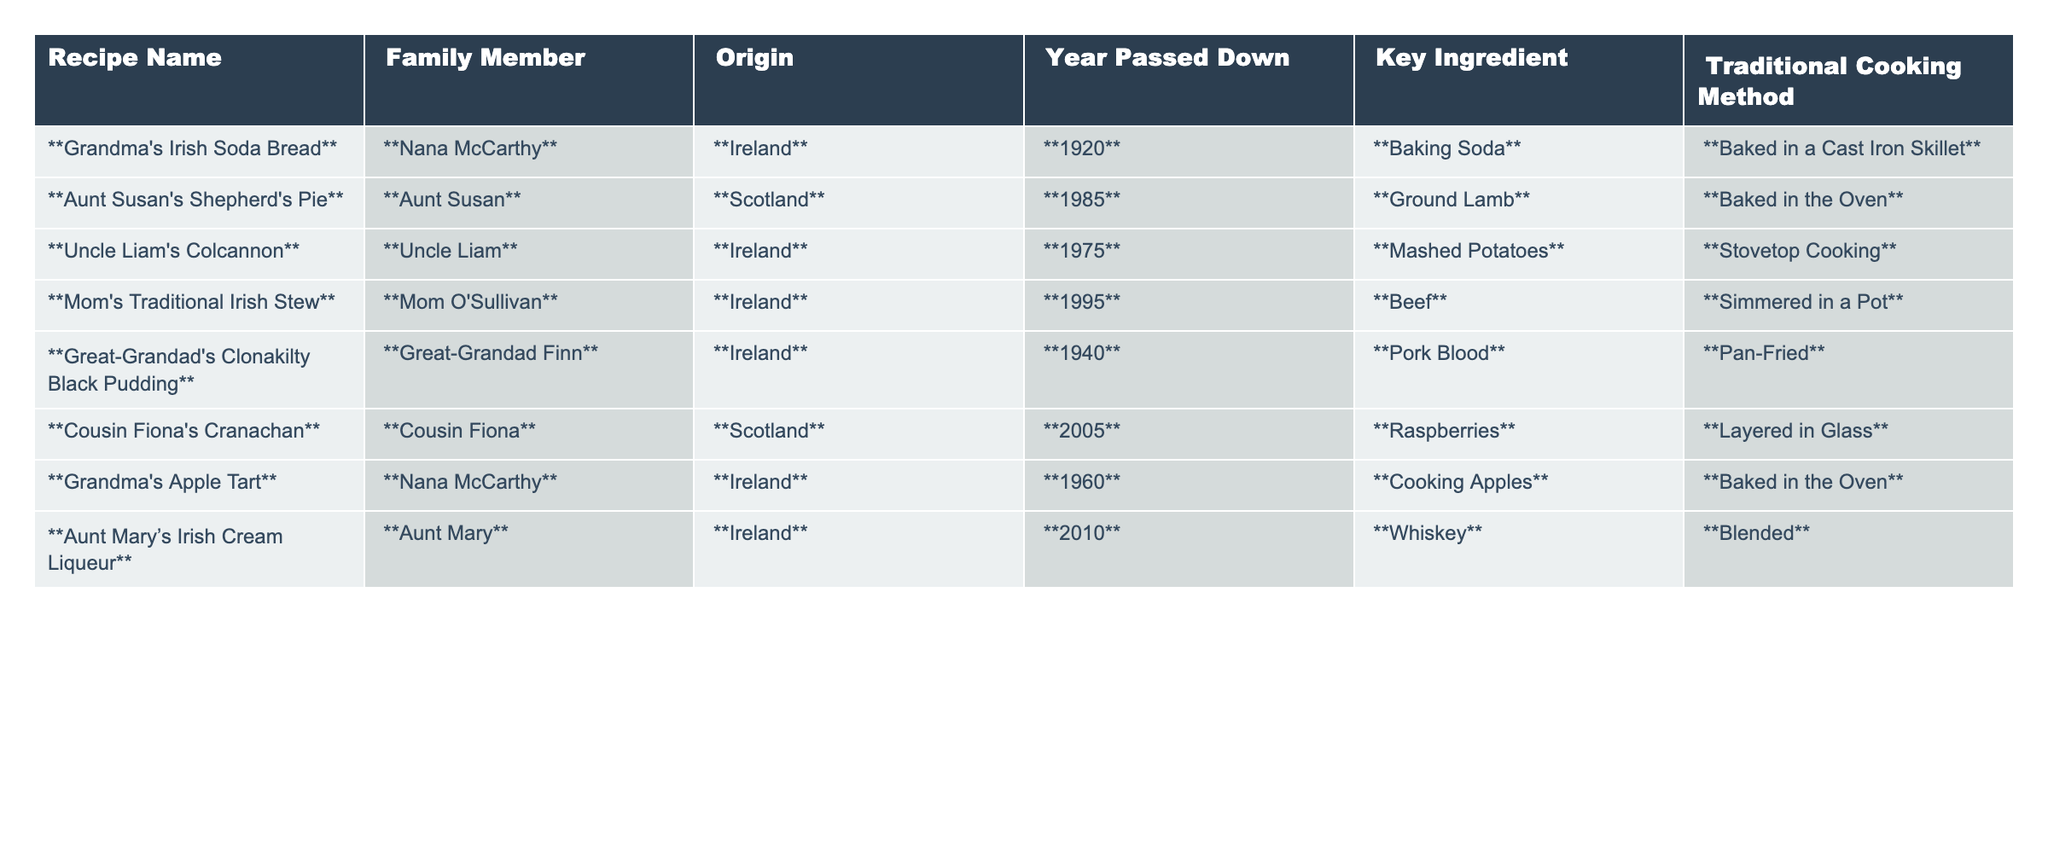What is the key ingredient in Grandma's Irish Soda Bread? The table shows that the key ingredient for Grandma's Irish Soda Bread is Baking Soda.
Answer: Baking Soda Which family member is associated with Aunt Susan's Shepherd's Pie? From the table, Aunt Susan is the family member associated with her Shepherd's Pie.
Answer: Aunt Susan When was Great-Grandad's Clonakilty Black Pudding passed down? The year Great-Grandad's Clonakilty Black Pudding was passed down is listed as 1940 in the table.
Answer: 1940 Is Mom's Traditional Irish Stew made with pork? The table indicates that Mom's Traditional Irish Stew is made with beef, not pork.
Answer: No What recipe has been passed down most recently? Looking at the years passed down, Cousin Fiona's Cranachan (2005) is the most recent.
Answer: Cousin Fiona's Cranachan Which two recipes feature a key ingredient related to potatoes? From the table, Uncle Liam's Colcannon (Mashed Potatoes) and Aunt Susan's Shepherd's Pie (Ground Lamb, but traditionally has potatoes) relate to potatoes, but only Colcannon explicitly has mashed potatoes.
Answer: Uncle Liam's Colcannon How many recipes were passed down in the 20th century? Analyzing the years listed, the recipes passed down before 2000 are Grandma's Irish Soda Bread (1920), Great-Grandad's Clonakilty Black Pudding (1940), Grandma's Apple Tart (1960), Uncle Liam's Colcannon (1975), Aunt Susan's Shepherd's Pie (1985), and Mom's Traditional Irish Stew (1995) totaling 6.
Answer: 6 What traditional cooking method is used for Aunt Mary’s Irish Cream Liqueur? The cooking method for Aunt Mary’s Irish Cream Liqueur, as shown in the table, is blending.
Answer: Blended Is there a recipe for a dessert in this table? Yes, the table includes Grandma's Apple Tart, which is a dessert.
Answer: Yes What is the average year of recipes passed down? Adding the years (1920 + 1985 + 1975 + 1995 + 1940 + 2005 + 1960 + 2010) gives us 15960. Dividing by 8 (the number of recipes) results in an average year of 1995.
Answer: 1995 Which country has the most recipes listed in this table? By examining the table, Ireland has 5 recipes, while Scotland has 3, making Ireland the country with the most recipes.
Answer: Ireland 